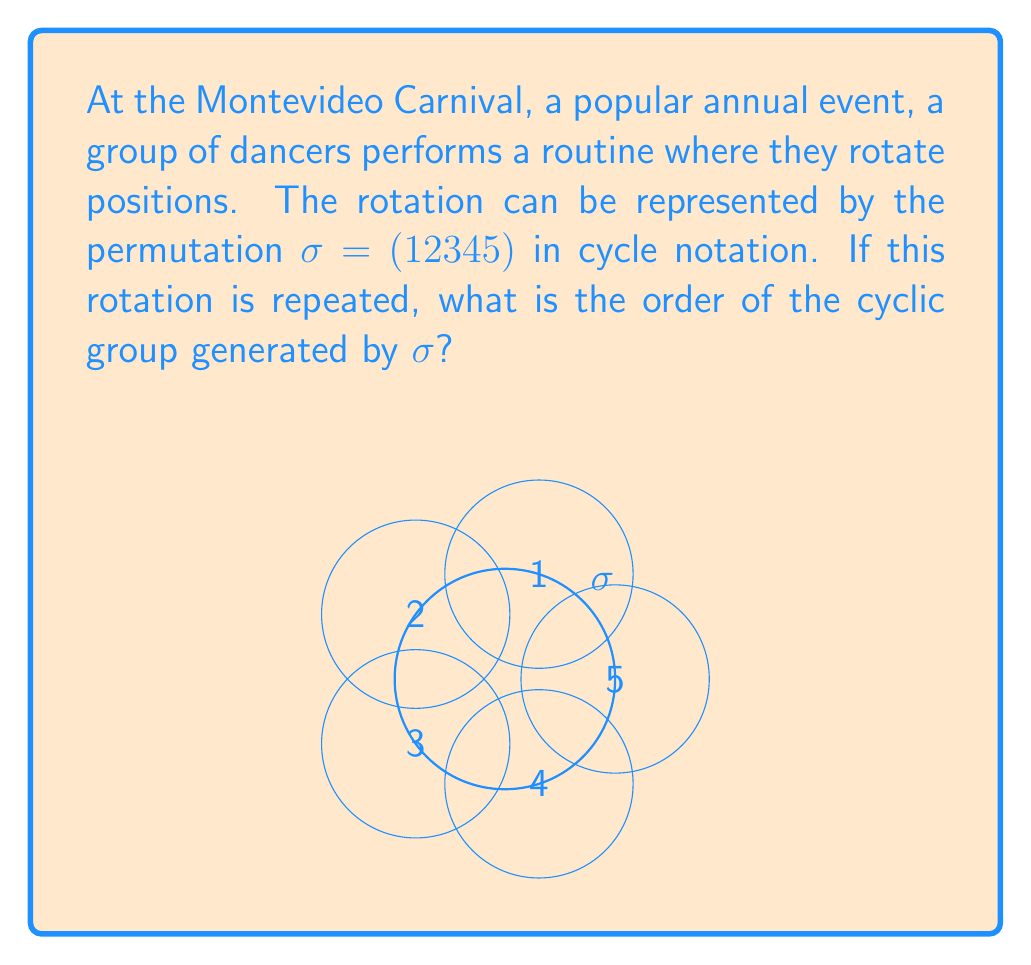Could you help me with this problem? To determine the order of the cyclic group generated by $\sigma$, we need to find the smallest positive integer $n$ such that $\sigma^n = e$ (the identity permutation). Let's follow these steps:

1) First, let's see what happens when we apply $\sigma$ multiple times:

   $\sigma = (1 2 3 4 5)$
   $\sigma^2 = (1 3 5 2 4)$
   $\sigma^3 = (1 4 2 5 3)$
   $\sigma^4 = (1 5 4 3 2)$
   $\sigma^5 = (1)(2)(3)(4)(5) = e$

2) We see that $\sigma^5 = e$, which means that after 5 applications of $\sigma$, we return to the identity permutation.

3) This is the smallest positive integer for which $\sigma^n = e$, as we can see that $\sigma, \sigma^2, \sigma^3,$ and $\sigma^4$ are all distinct from $e$.

4) The order of an element in a group is defined as the smallest positive integer $n$ such that $a^n = e$, where $a$ is the element and $e$ is the identity.

5) Therefore, the order of $\sigma$ is 5.

6) In a cyclic group generated by an element, the order of the group is equal to the order of the generating element.

Thus, the order of the cyclic group generated by $\sigma$ is 5.
Answer: 5 